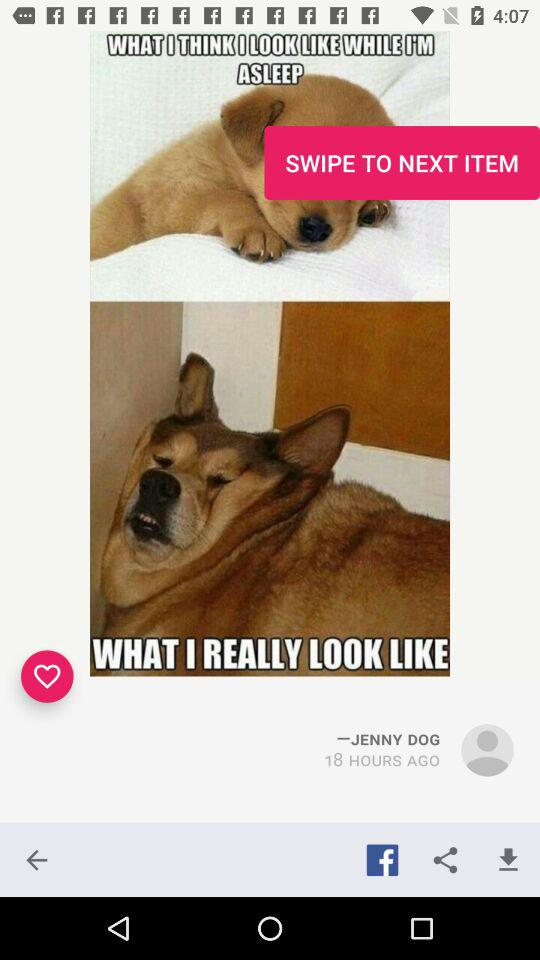Where is Jenny Dog located?
When the provided information is insufficient, respond with <no answer>. <no answer> 